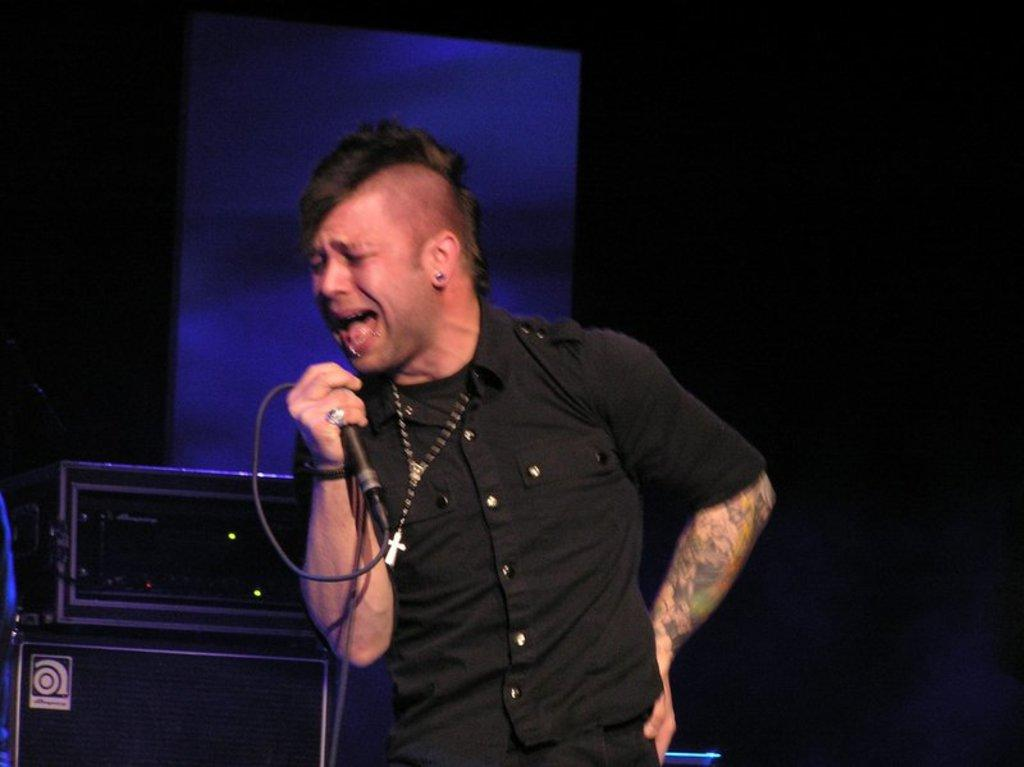Who is the main subject in the image? There is a man in the middle of the image. What is the man holding in the image? The man is holding a microphone. What else can be seen in the image besides the man? There are musical instruments visible behind the man. How would you describe the lighting in the image? The background of the image is dark. What type of horse can be seen on the canvas in the image? There is no canvas or horse present in the image. What property does the man own in the image? The image does not provide any information about the man owning a property. 